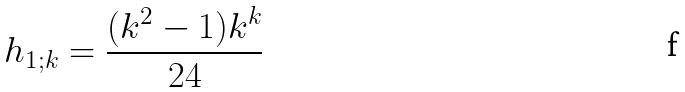<formula> <loc_0><loc_0><loc_500><loc_500>h _ { 1 ; k } = \frac { ( k ^ { 2 } - 1 ) k ^ { k } } { 2 4 }</formula> 